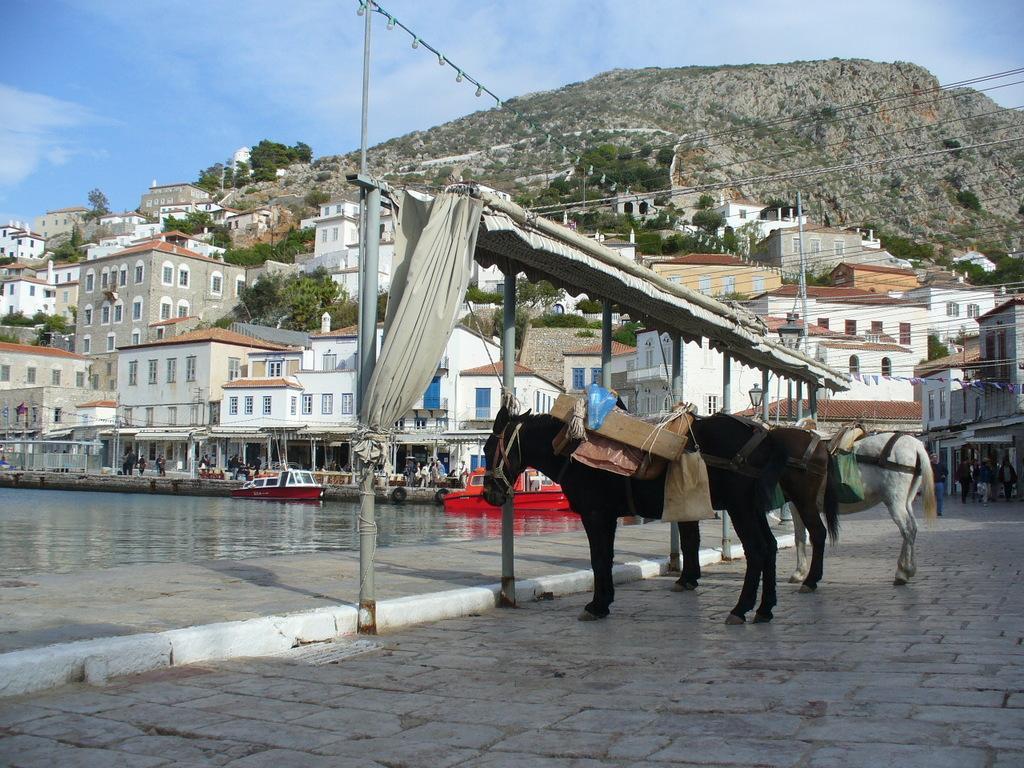Please provide a concise description of this image. There are three horses tied with the threads which are connected to the poles. Above them, there is a roof which is having a white color curtain. In the background, there are boats on the water, there are buildings which are having glass windows, there are buildings and trees on the hill, there is a mountain and there are clouds in the blue sky. 